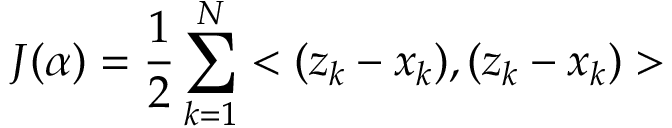Convert formula to latex. <formula><loc_0><loc_0><loc_500><loc_500>J ( \alpha ) = \frac { 1 } { 2 } \sum _ { k = 1 } ^ { N } < ( z _ { k } - x _ { k } ) , ( z _ { k } - x _ { k } ) ></formula> 